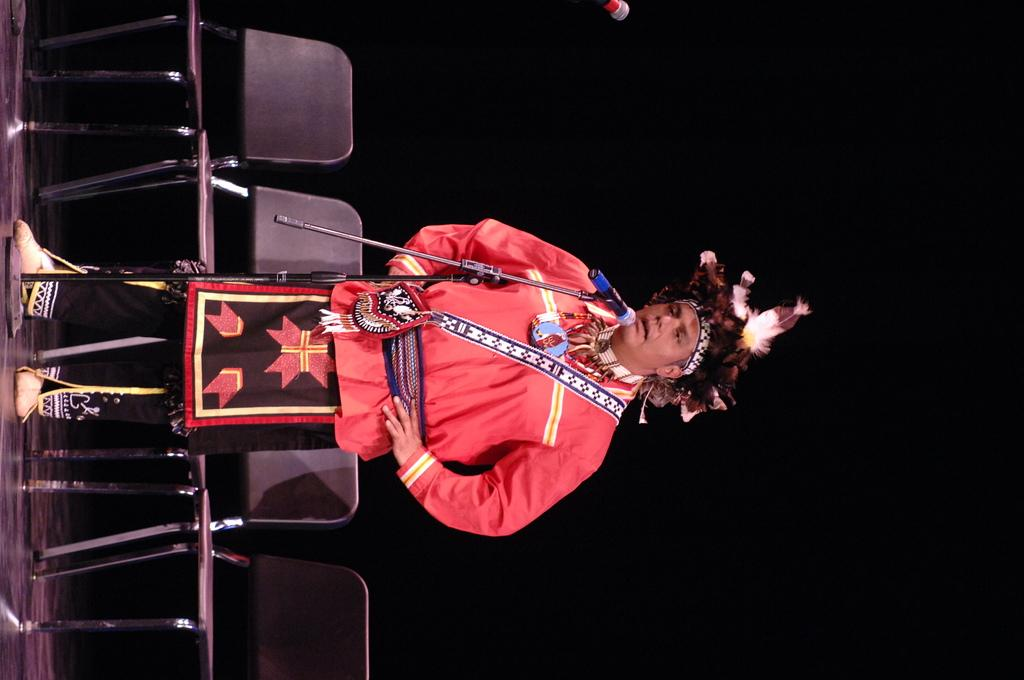What is the man in the image doing? The man is standing on a stage. What is the man using to amplify his voice? There is a mic with a stand in front of the man. What type of seating is available in the image? There are chairs on the floor. What type of grass is growing on the stage in the image? There is no grass visible in the image; the stage is indoors. 